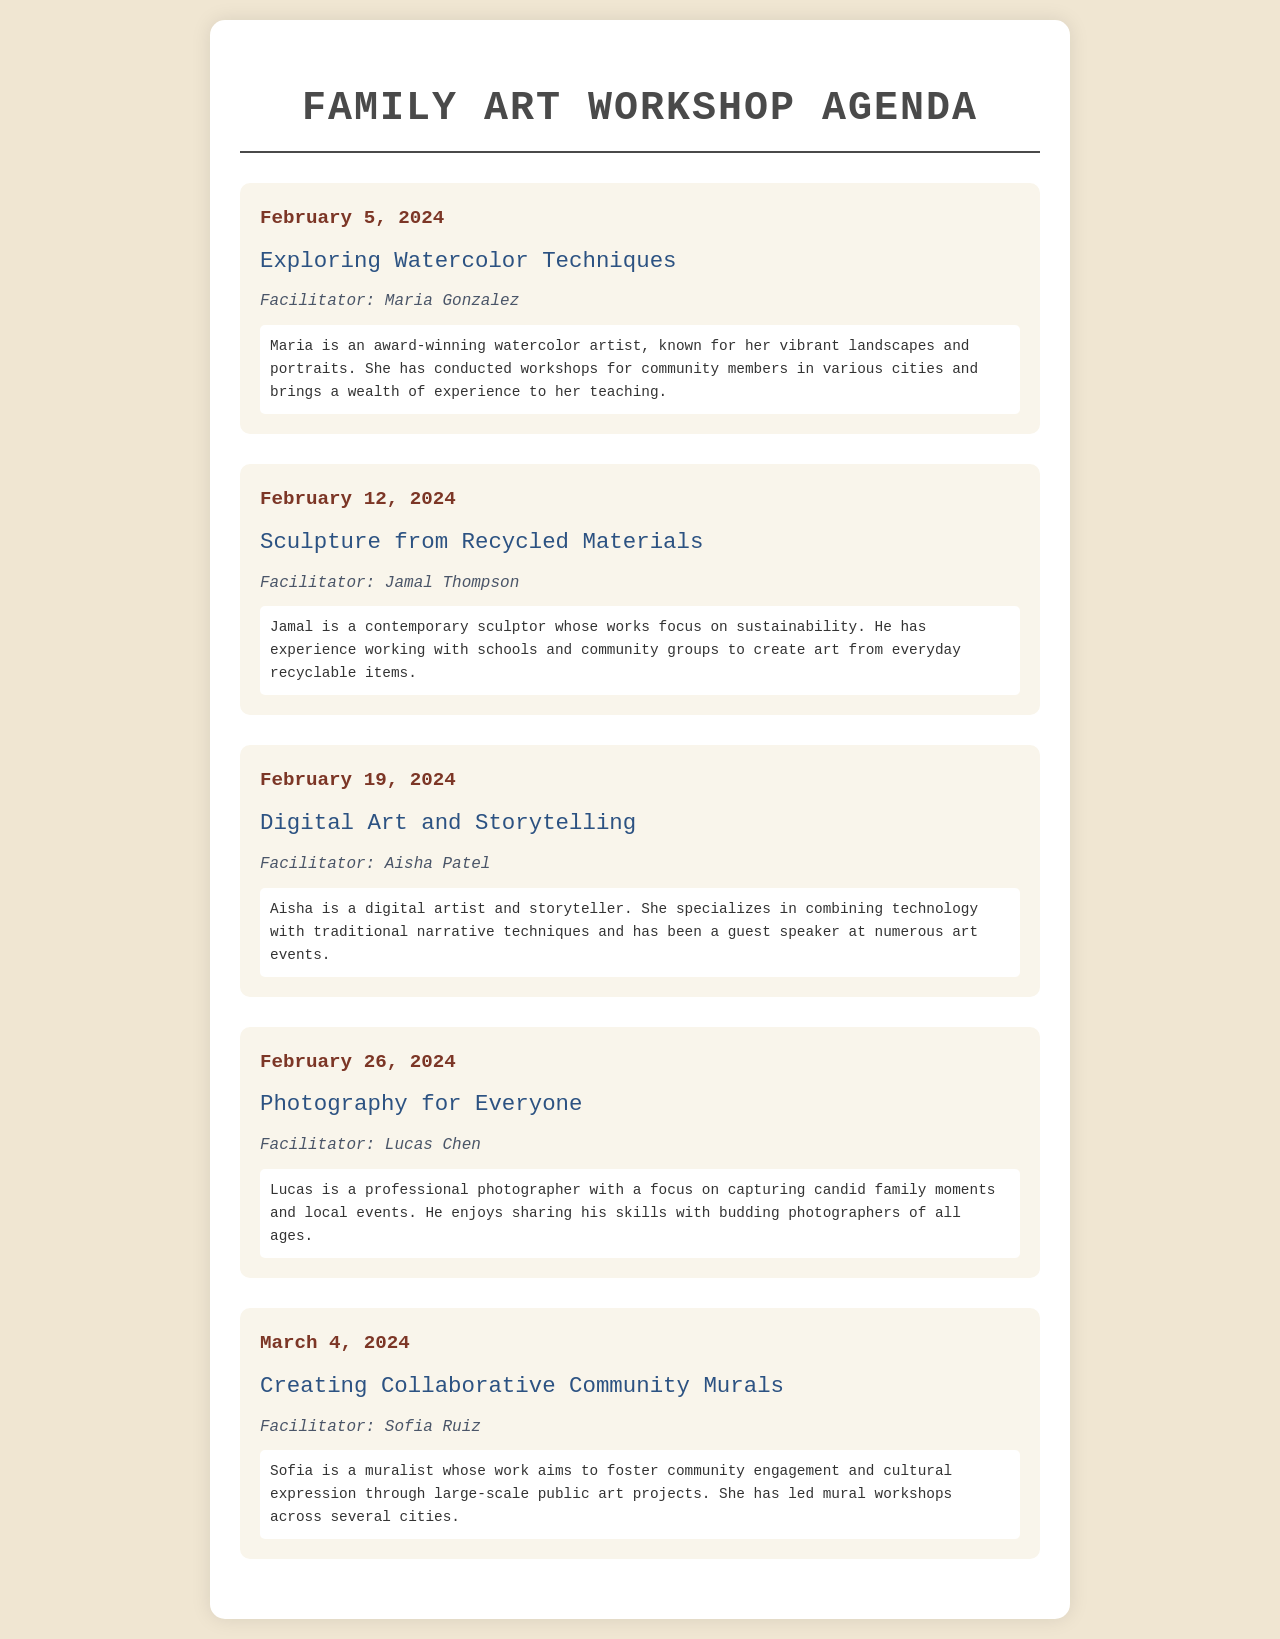What is the date of the first workshop? The first workshop is scheduled for February 5, 2024.
Answer: February 5, 2024 Who is the facilitator for the workshop on February 12, 2024? The facilitator for the February 12 workshop is Jamal Thompson.
Answer: Jamal Thompson What topic will be covered in the workshop on February 19, 2024? The topic for the February 19 workshop is Digital Art and Storytelling.
Answer: Digital Art and Storytelling How many workshops are featured in the agenda? There are a total of five workshops listed in the agenda.
Answer: Five Which facilitator focuses on sustainability? The facilitator who focuses on sustainability is Jamal Thompson.
Answer: Jamal Thompson What is the main theme of Sofia Ruiz's workshop? The main theme of Sofia Ruiz's workshop is creating collaborative community murals.
Answer: Collaborative Community Murals What type of art does Aisha Patel specialize in? Aisha Patel specializes in digital art and storytelling.
Answer: Digital art and storytelling On what date will the photography workshop take place? The photography workshop is scheduled for February 26, 2024.
Answer: February 26, 2024 What does Maria Gonzalez focus on as an artist? Maria Gonzalez focuses on watercolor techniques as an artist.
Answer: Watercolor techniques 